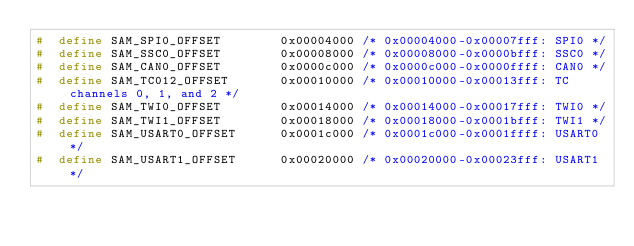Convert code to text. <code><loc_0><loc_0><loc_500><loc_500><_C_>#  define SAM_SPI0_OFFSET        0x00004000 /* 0x00004000-0x00007fff: SPI0 */
#  define SAM_SSC0_OFFSET        0x00008000 /* 0x00008000-0x0000bfff: SSC0 */
#  define SAM_CAN0_OFFSET        0x0000c000 /* 0x0000c000-0x0000ffff: CAN0 */
#  define SAM_TC012_OFFSET       0x00010000 /* 0x00010000-0x00013fff: TC channels 0, 1, and 2 */
#  define SAM_TWI0_OFFSET        0x00014000 /* 0x00014000-0x00017fff: TWI0 */
#  define SAM_TWI1_OFFSET        0x00018000 /* 0x00018000-0x0001bfff: TWI1 */
#  define SAM_USART0_OFFSET      0x0001c000 /* 0x0001c000-0x0001ffff: USART0 */
#  define SAM_USART1_OFFSET      0x00020000 /* 0x00020000-0x00023fff: USART1 */</code> 